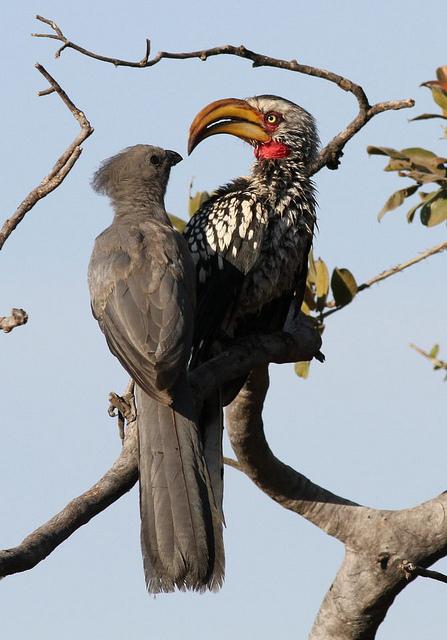Are the birds filing?
Answer briefly. No. Are these the same type of birds?
Quick response, please. No. Is this birds beak long?
Keep it brief. Yes. What types of birds are these?
Keep it brief. Vultures. 